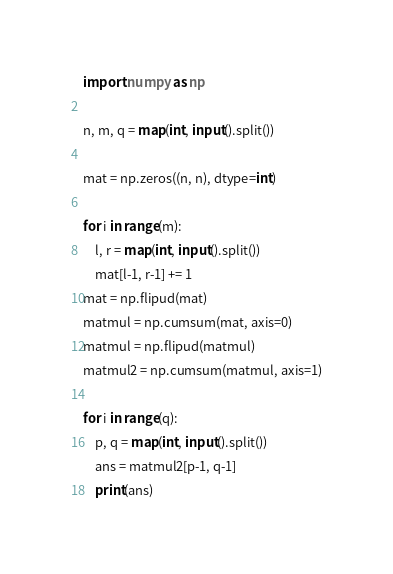<code> <loc_0><loc_0><loc_500><loc_500><_Python_>import numpy as np

n, m, q = map(int, input().split())

mat = np.zeros((n, n), dtype=int)

for i in range(m):
    l, r = map(int, input().split())
    mat[l-1, r-1] += 1
mat = np.flipud(mat)
matmul = np.cumsum(mat, axis=0)
matmul = np.flipud(matmul)
matmul2 = np.cumsum(matmul, axis=1)

for i in range(q):
    p, q = map(int, input().split())
    ans = matmul2[p-1, q-1]
    print(ans)</code> 